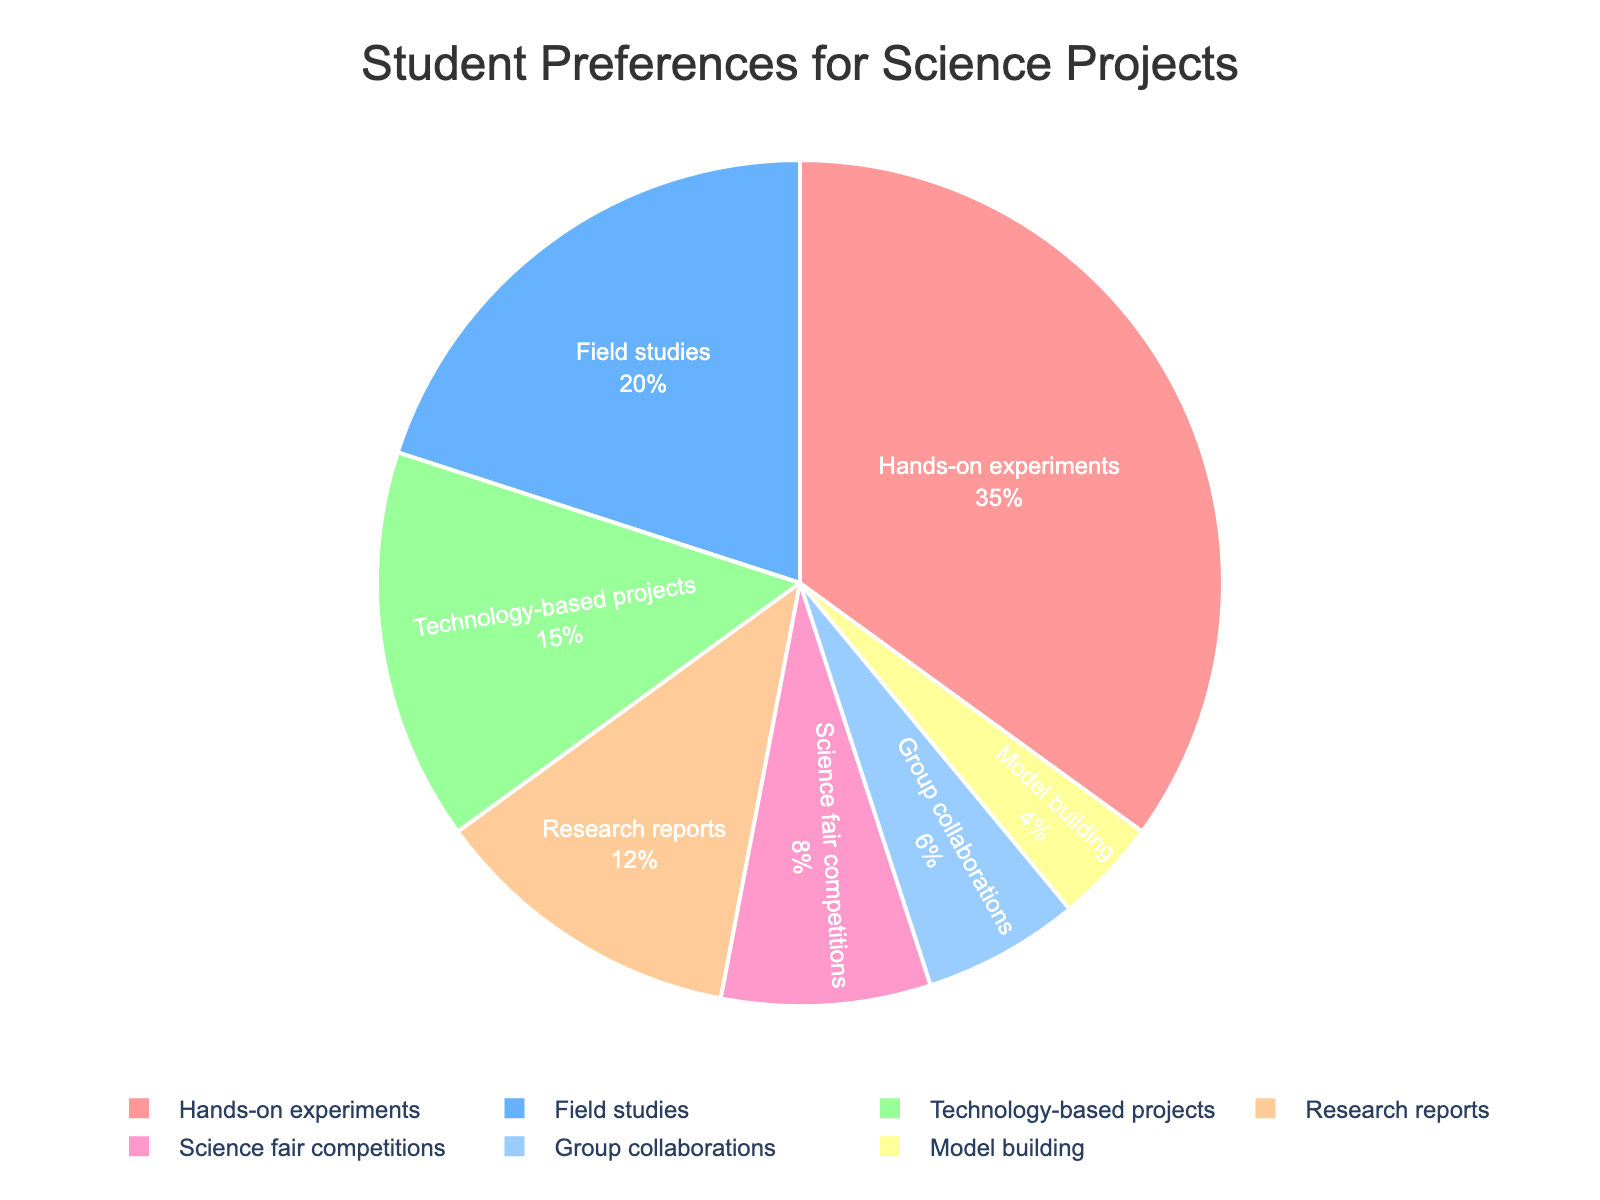What percentage of students prefer Technology-based projects? The figure shows the categories and their corresponding percentages. Look for "Technology-based projects" in the chart, and note the percentage associated with it.
Answer: 15% Which type of science project is favored by students the most? To find the most preferred category, look for the slice with the largest percentage in the pie chart. "Hands-on experiments" has the largest slice, indicating it is the most favored.
Answer: Hands-on experiments What is the combined percentage of students who prefer Field studies and Research reports? Find the individual percentages for "Field studies" and "Research reports" from the chart. Add these percentages together: 20% (Field studies) + 12% (Research reports) = 32%.
Answer: 32% Are more students interested in Science fair competitions or in Group collaborations? Compare the slices for "Science fair competitions" and "Group collaborations." The percentage for "Science fair competitions" is 8%, and for "Group collaborations" is 6%. Since 8% is greater than 6%, more students are interested in Science fair competitions.
Answer: Science fair competitions What is the percentage difference between the most and least preferred science project types? Identify the most preferred ("Hands-on experiments" at 35%) and the least preferred ("Model building" at 4%) project types. Subtract the least preferred percentage from the most preferred: 35% - 4% = 31%.
Answer: 31% Which category would have 1/2 of its proportion if only half of the students who prefer Hands-on experiments were considered? First, find the percentage for Hands-on experiments, which is 35%. Half of this is 35% / 2 = 17.5%. This new percentage would be below the proportion shown for Field studies (20%), positioning it correctly for answering the question.
Answer: 17.5% If we combine the preferences for Group collaborations, Model building, and Science fair competitions, is the resulting percentage greater than that for Hands-on experiments? Add the percentages for Group collaborations (6%), Model building (4%), and Science fair competitions (8%): 6% + 4% + 8% = 18%. The preference for Hands-on experiments is 35%, which is greater than the total combined preferences of these three categories.
Answer: No What is the visual color used to represent Research reports in the pie chart? Refer to the color-coded slices in the chart and identify the color associated with "Research reports." It is shown in an orange-like shade.
Answer: Orange-like Which color represents the Technology-based projects category? Look at the pie chart to see the color that corresponds to "Technology-based projects," which is depicted in a shade of light blue.
Answer: Light blue Is the combined preference for Group collaborations and Model building less than 10%? Add the percentages for Group collaborations (6%) and Model building (4%): 6% + 4% = 10%. The combined percentage is exactly 10%, so it is not less than 10%.
Answer: No 